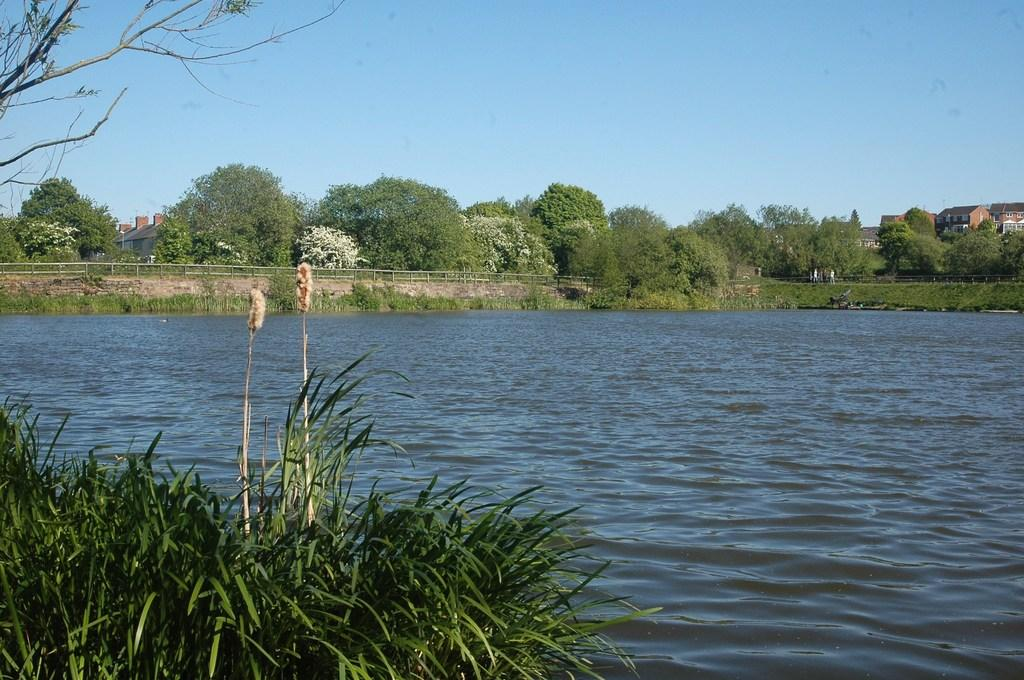What type of vegetation can be seen in the image? There is grass and flowers in the image. What natural element is present in the image? There is water in the image. How is the tree depicted in the image? There is a truncated tree in the image. What can be seen in the background of the image? In the background of the image, there are plants, grass, a fence, trees, buildings, and the sky. How many pockets are visible on the flowers in the image? There are no pockets on the flowers in the image, as flowers do not have pockets. What type of cattle can be seen grazing in the water in the image? There are no cattle present in the image; it features grass, flowers, water, and a truncated tree. 